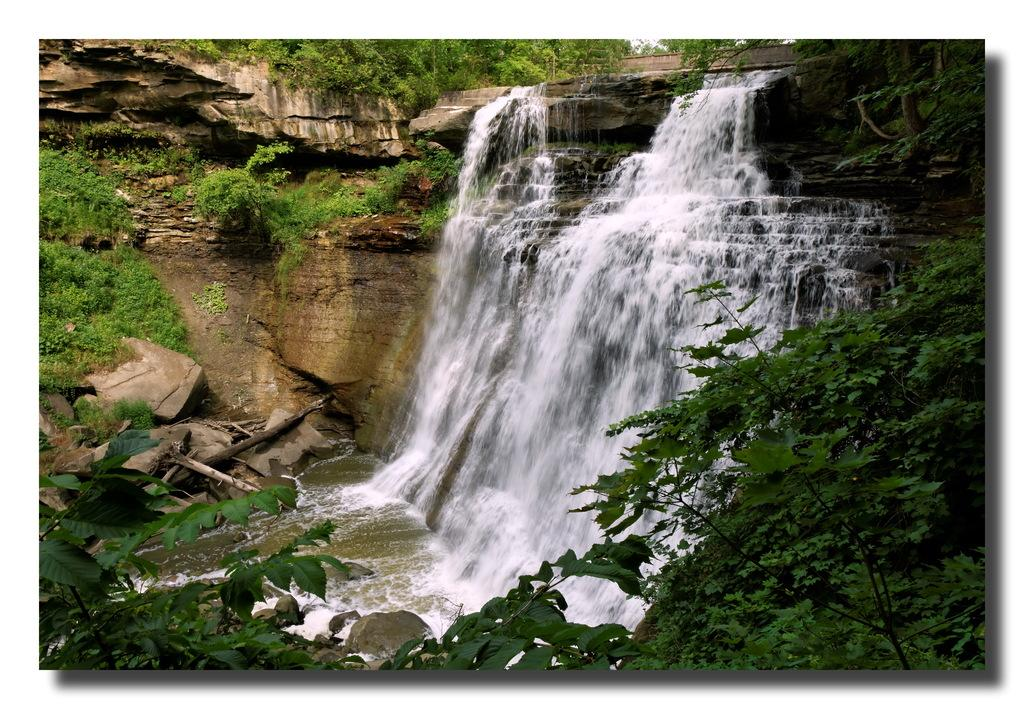What natural feature is the main subject of the image? There is a waterfall in the image. What type of vegetation can be seen in the image? There are plants in the image. What type of breakfast is being served on the point in the image? There is no point or breakfast present in the image; it features a waterfall and plants. 